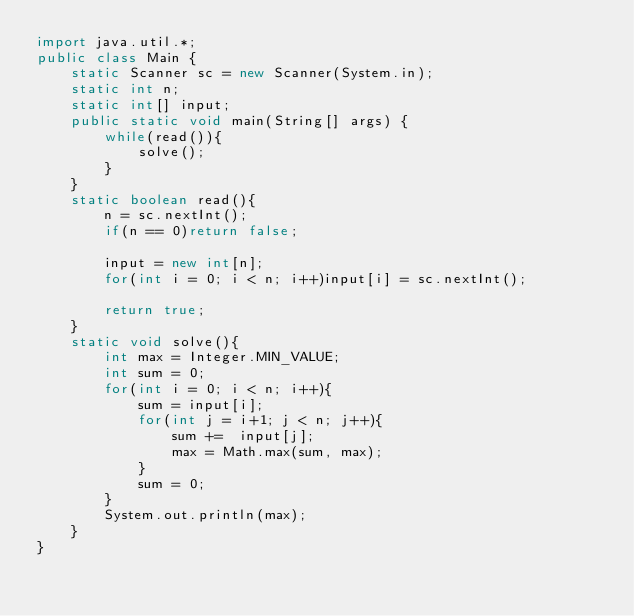<code> <loc_0><loc_0><loc_500><loc_500><_Java_>import java.util.*;
public class Main {
    static Scanner sc = new Scanner(System.in);
    static int n;
    static int[] input;
    public static void main(String[] args) {
        while(read()){
            solve();
        }
    }
    static boolean read(){
        n = sc.nextInt();
        if(n == 0)return false;

        input = new int[n];
        for(int i = 0; i < n; i++)input[i] = sc.nextInt();

        return true;
    }
    static void solve(){
        int max = Integer.MIN_VALUE;
        int sum = 0;
        for(int i = 0; i < n; i++){
            sum = input[i];
            for(int j = i+1; j < n; j++){
                sum +=  input[j];
                max = Math.max(sum, max);
            }
            sum = 0;
        }
        System.out.println(max);
    }
}</code> 